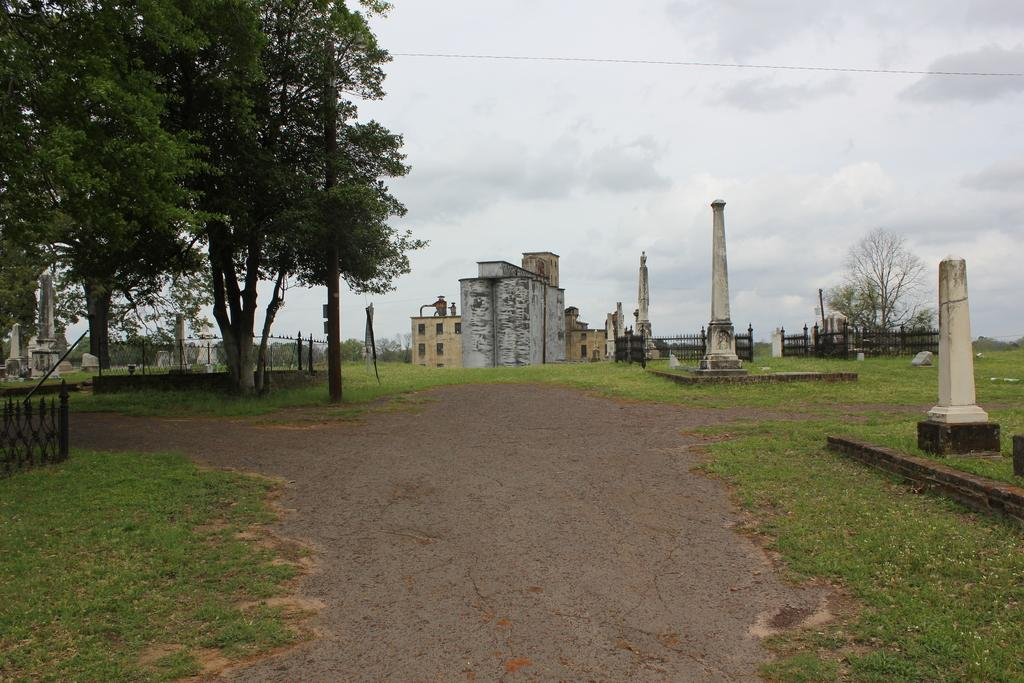What type of structures can be seen in the image? There are buildings in the image. What architectural elements are present in the image? There are pillars in the image. What type of barrier can be seen in the image? There is a fence in the image. What part of the natural environment is visible in the image? The ground and trees are visible in the image. What part of the sky is visible in the image? The sky is visible in the image. How many rings are visible on the trees in the image? There are no rings visible on the trees in the image, as rings are not a visible feature of trees in photographs. What degree of difficulty is required to climb the fence in the image? The image does not provide information about the difficulty of climbing the fence, nor does it show any people attempting to climb it. 